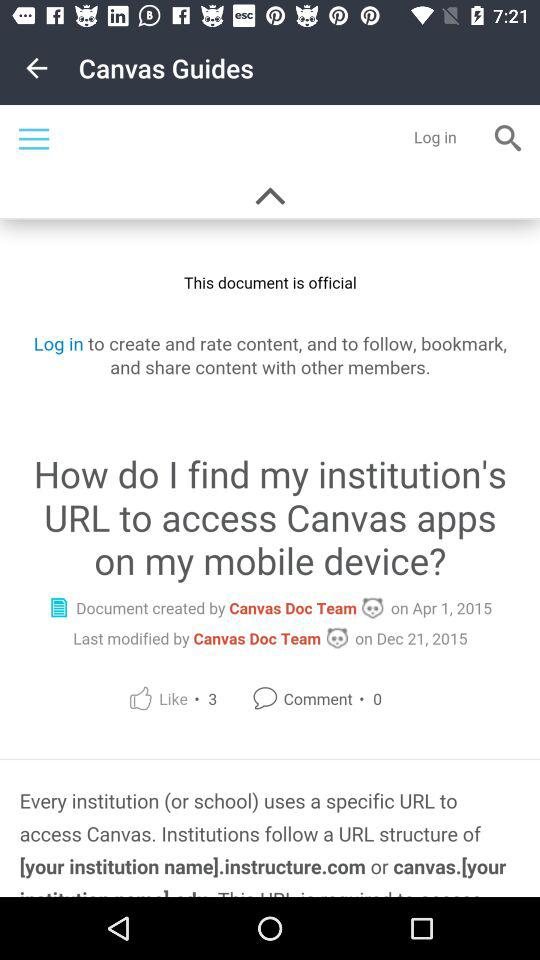On what date was the document last modified? The document was last modified on December 21, 2015. 